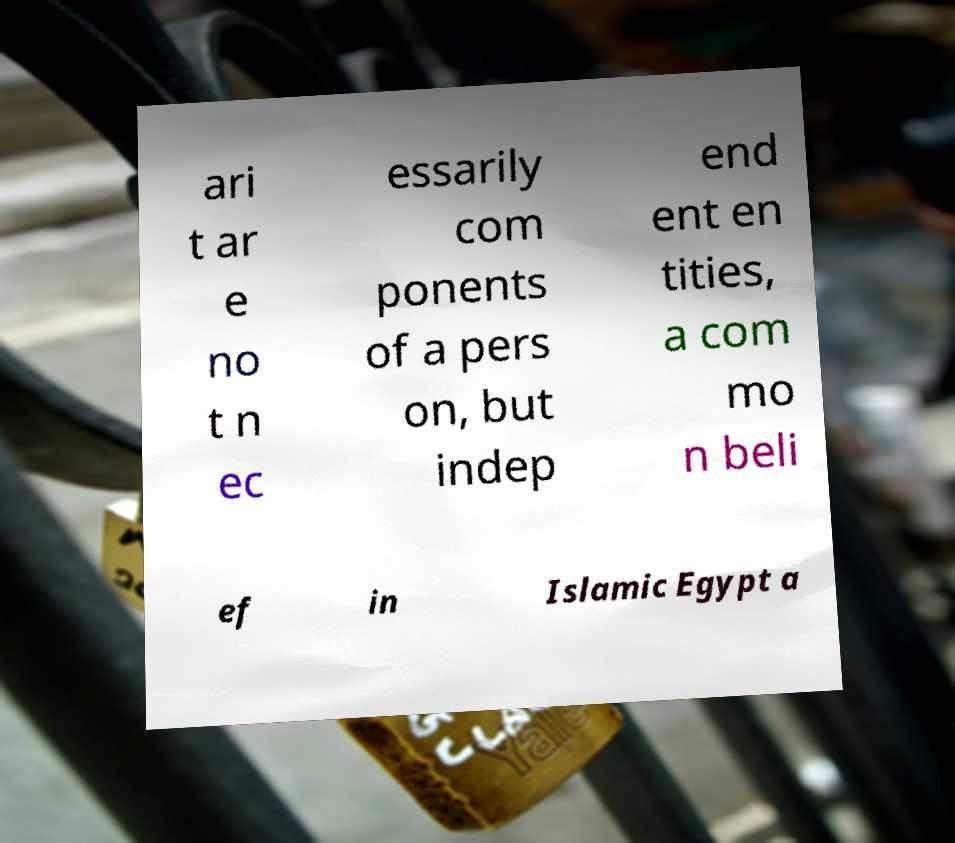Please read and relay the text visible in this image. What does it say? ari t ar e no t n ec essarily com ponents of a pers on, but indep end ent en tities, a com mo n beli ef in Islamic Egypt a 